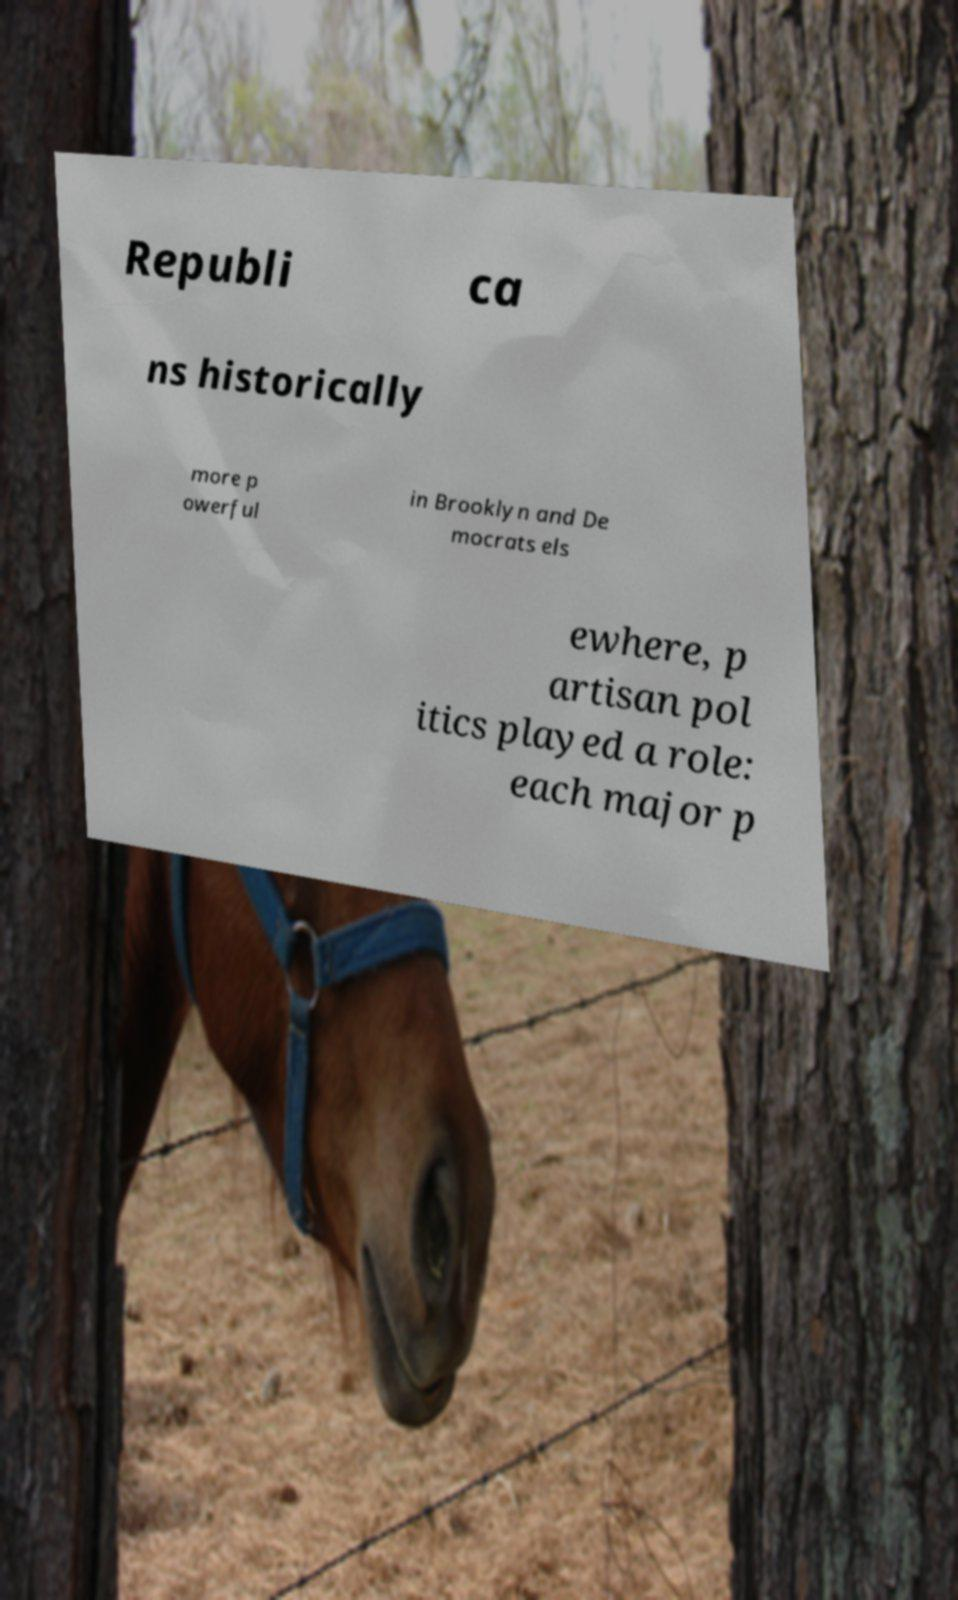Please identify and transcribe the text found in this image. Republi ca ns historically more p owerful in Brooklyn and De mocrats els ewhere, p artisan pol itics played a role: each major p 